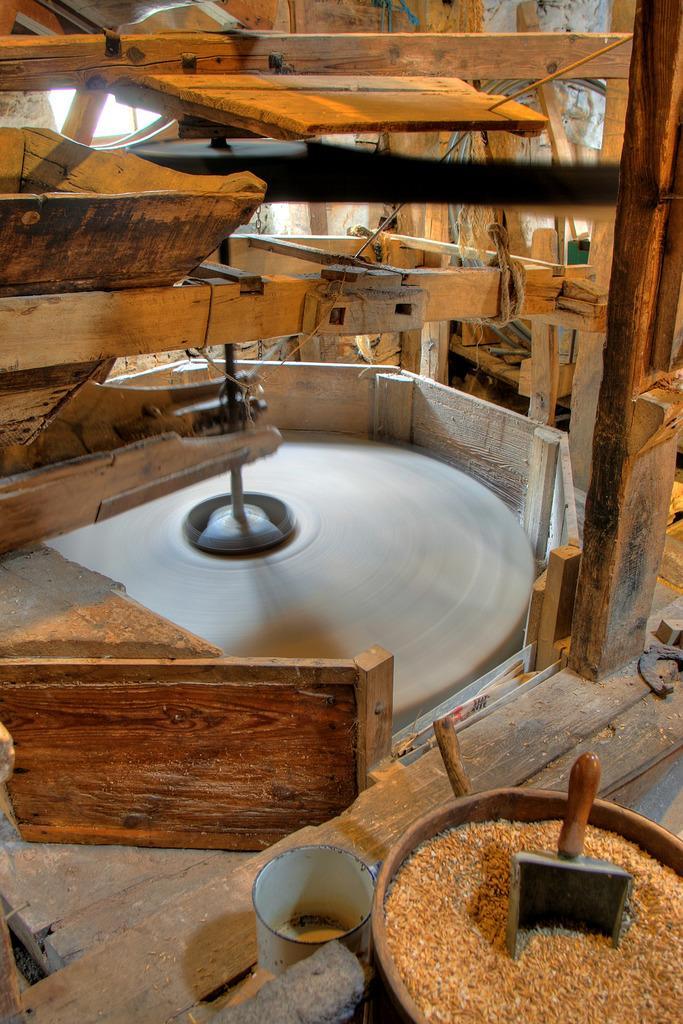Can you describe this image briefly? In this picture there is an wooden object and there are few grains in the right bottom corner. 